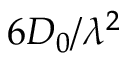<formula> <loc_0><loc_0><loc_500><loc_500>6 D _ { 0 } / \lambda ^ { 2 }</formula> 